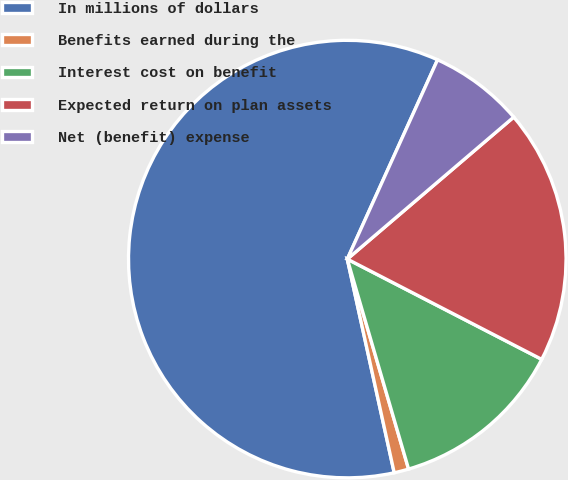<chart> <loc_0><loc_0><loc_500><loc_500><pie_chart><fcel>In millions of dollars<fcel>Benefits earned during the<fcel>Interest cost on benefit<fcel>Expected return on plan assets<fcel>Net (benefit) expense<nl><fcel>60.21%<fcel>1.08%<fcel>12.9%<fcel>18.82%<fcel>6.99%<nl></chart> 